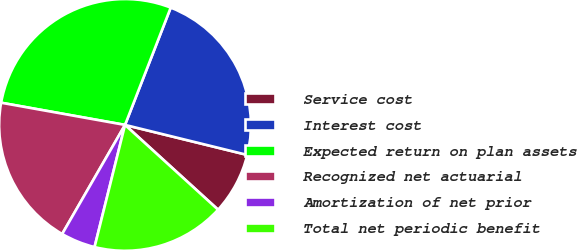Convert chart to OTSL. <chart><loc_0><loc_0><loc_500><loc_500><pie_chart><fcel>Service cost<fcel>Interest cost<fcel>Expected return on plan assets<fcel>Recognized net actuarial<fcel>Amortization of net prior<fcel>Total net periodic benefit<nl><fcel>7.93%<fcel>22.92%<fcel>28.09%<fcel>19.5%<fcel>4.43%<fcel>17.13%<nl></chart> 